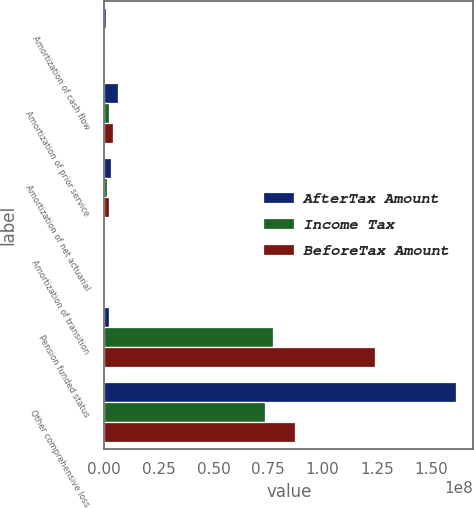<chart> <loc_0><loc_0><loc_500><loc_500><stacked_bar_chart><ecel><fcel>Amortization of cash flow<fcel>Amortization of prior service<fcel>Amortization of net actuarial<fcel>Amortization of transition<fcel>Pension funded status<fcel>Other comprehensive loss<nl><fcel>AfterTax Amount<fcel>693000<fcel>6.128e+06<fcel>3.253e+06<fcel>153000<fcel>2.351e+06<fcel>1.61047e+08<nl><fcel>Income Tax<fcel>266000<fcel>2.351e+06<fcel>1.25e+06<fcel>60000<fcel>7.7487e+07<fcel>7.356e+07<nl><fcel>BeforeTax Amount<fcel>427000<fcel>3.777e+06<fcel>2.003e+06<fcel>93000<fcel>1.24301e+08<fcel>8.7487e+07<nl></chart> 